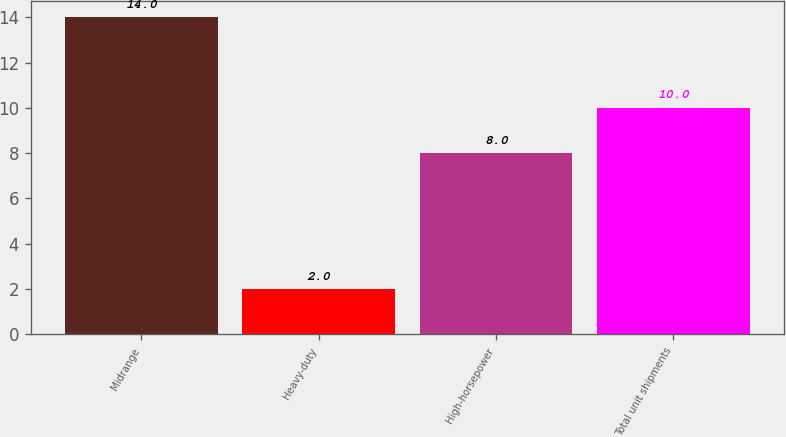Convert chart to OTSL. <chart><loc_0><loc_0><loc_500><loc_500><bar_chart><fcel>Midrange<fcel>Heavy-duty<fcel>High-horsepower<fcel>Total unit shipments<nl><fcel>14<fcel>2<fcel>8<fcel>10<nl></chart> 